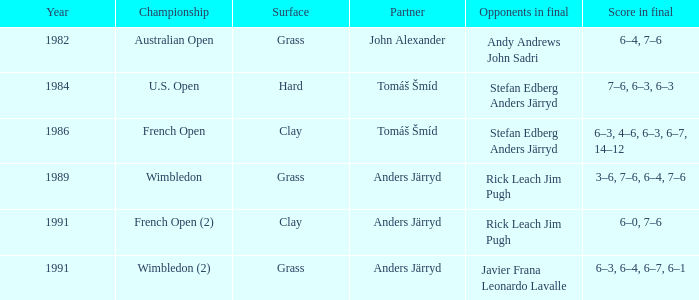What was the surface when he played with John Alexander?  Grass. Could you parse the entire table? {'header': ['Year', 'Championship', 'Surface', 'Partner', 'Opponents in final', 'Score in final'], 'rows': [['1982', 'Australian Open', 'Grass', 'John Alexander', 'Andy Andrews John Sadri', '6–4, 7–6'], ['1984', 'U.S. Open', 'Hard', 'Tomáš Šmíd', 'Stefan Edberg Anders Järryd', '7–6, 6–3, 6–3'], ['1986', 'French Open', 'Clay', 'Tomáš Šmíd', 'Stefan Edberg Anders Järryd', '6–3, 4–6, 6–3, 6–7, 14–12'], ['1989', 'Wimbledon', 'Grass', 'Anders Järryd', 'Rick Leach Jim Pugh', '3–6, 7–6, 6–4, 7–6'], ['1991', 'French Open (2)', 'Clay', 'Anders Järryd', 'Rick Leach Jim Pugh', '6–0, 7–6'], ['1991', 'Wimbledon (2)', 'Grass', 'Anders Järryd', 'Javier Frana Leonardo Lavalle', '6–3, 6–4, 6–7, 6–1']]} 